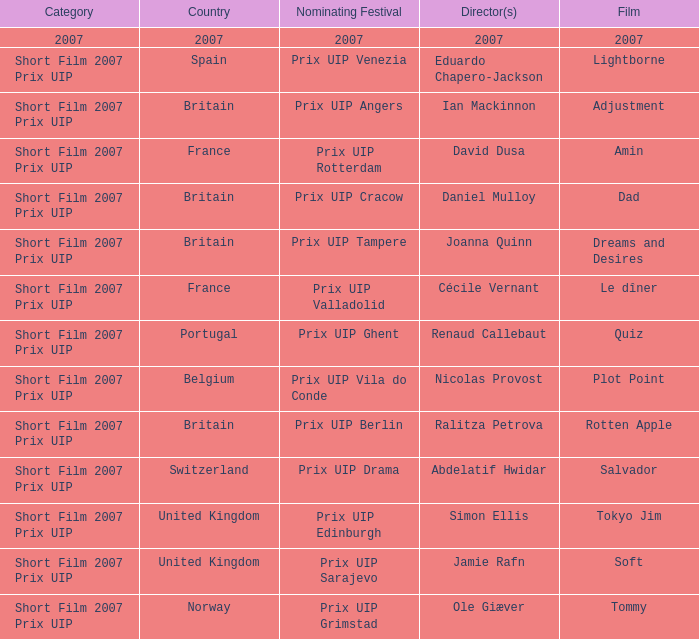What country was the prix uip ghent nominating festival? Portugal. 